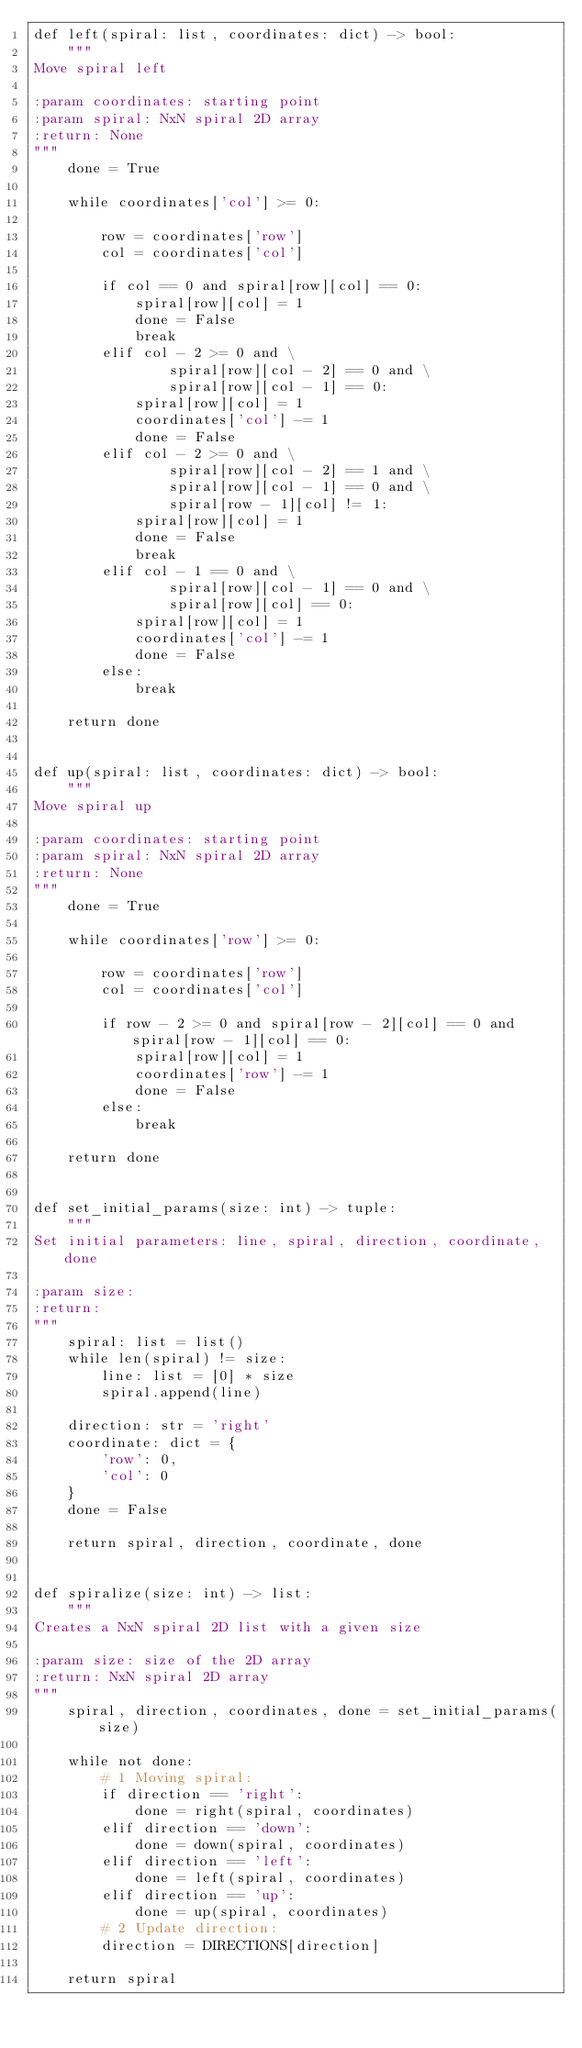<code> <loc_0><loc_0><loc_500><loc_500><_Python_>def left(spiral: list, coordinates: dict) -> bool:
    """
Move spiral left

:param coordinates: starting point
:param spiral: NxN spiral 2D array
:return: None
"""
    done = True

    while coordinates['col'] >= 0:

        row = coordinates['row']
        col = coordinates['col']

        if col == 0 and spiral[row][col] == 0:
            spiral[row][col] = 1
            done = False
            break
        elif col - 2 >= 0 and \
                spiral[row][col - 2] == 0 and \
                spiral[row][col - 1] == 0:
            spiral[row][col] = 1
            coordinates['col'] -= 1
            done = False
        elif col - 2 >= 0 and \
                spiral[row][col - 2] == 1 and \
                spiral[row][col - 1] == 0 and \
                spiral[row - 1][col] != 1:
            spiral[row][col] = 1
            done = False
            break
        elif col - 1 == 0 and \
                spiral[row][col - 1] == 0 and \
                spiral[row][col] == 0:
            spiral[row][col] = 1
            coordinates['col'] -= 1
            done = False
        else:
            break

    return done


def up(spiral: list, coordinates: dict) -> bool:
    """
Move spiral up

:param coordinates: starting point
:param spiral: NxN spiral 2D array
:return: None
"""
    done = True

    while coordinates['row'] >= 0:

        row = coordinates['row']
        col = coordinates['col']

        if row - 2 >= 0 and spiral[row - 2][col] == 0 and spiral[row - 1][col] == 0:
            spiral[row][col] = 1
            coordinates['row'] -= 1
            done = False
        else:
            break

    return done


def set_initial_params(size: int) -> tuple:
    """
Set initial parameters: line, spiral, direction, coordinate, done

:param size:
:return:
"""
    spiral: list = list()
    while len(spiral) != size:
        line: list = [0] * size
        spiral.append(line)

    direction: str = 'right'
    coordinate: dict = {
        'row': 0,
        'col': 0
    }
    done = False

    return spiral, direction, coordinate, done


def spiralize(size: int) -> list:
    """
Creates a NxN spiral 2D list with a given size

:param size: size of the 2D array
:return: NxN spiral 2D array
"""
    spiral, direction, coordinates, done = set_initial_params(size)

    while not done:
        # 1 Moving spiral:
        if direction == 'right':
            done = right(spiral, coordinates)
        elif direction == 'down':
            done = down(spiral, coordinates)
        elif direction == 'left':
            done = left(spiral, coordinates)
        elif direction == 'up':
            done = up(spiral, coordinates)
        # 2 Update direction:
        direction = DIRECTIONS[direction]

    return spiral
</code> 